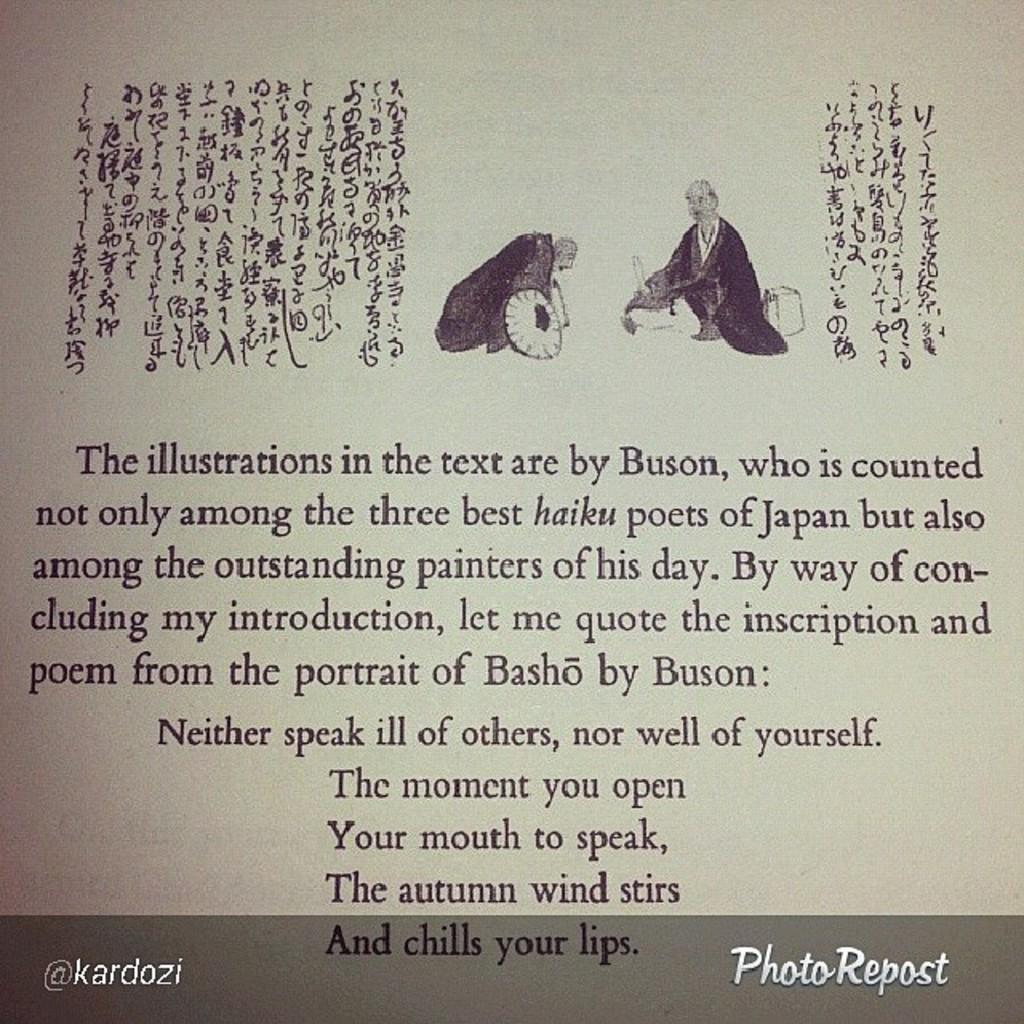<image>
Create a compact narrative representing the image presented. An introduction written for a book on haiku poets of Japan ends with a poem from The Portrait of Basho by Buson. 